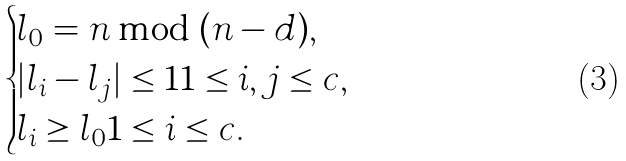<formula> <loc_0><loc_0><loc_500><loc_500>\begin{cases} l _ { 0 } = n \bmod ( n - d ) , \\ | l _ { i } - l _ { j } | \leq 1 1 \leq i , j \leq c , \\ l _ { i } \geq l _ { 0 } 1 \leq i \leq c . \end{cases}</formula> 